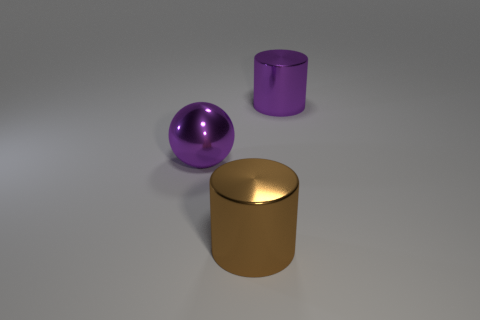Add 2 big purple shiny objects. How many objects exist? 5 Subtract all cylinders. How many objects are left? 1 Subtract all big purple shiny cylinders. Subtract all brown metallic cylinders. How many objects are left? 1 Add 2 big purple balls. How many big purple balls are left? 3 Add 3 large green matte balls. How many large green matte balls exist? 3 Subtract 0 gray blocks. How many objects are left? 3 